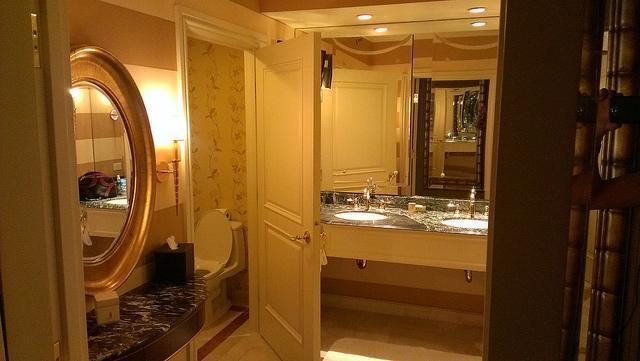How many sinks are in the bathroom?
Give a very brief answer. 2. 